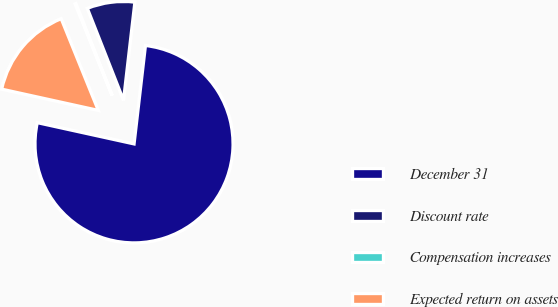Convert chart. <chart><loc_0><loc_0><loc_500><loc_500><pie_chart><fcel>December 31<fcel>Discount rate<fcel>Compensation increases<fcel>Expected return on assets<nl><fcel>76.61%<fcel>7.8%<fcel>0.15%<fcel>15.44%<nl></chart> 